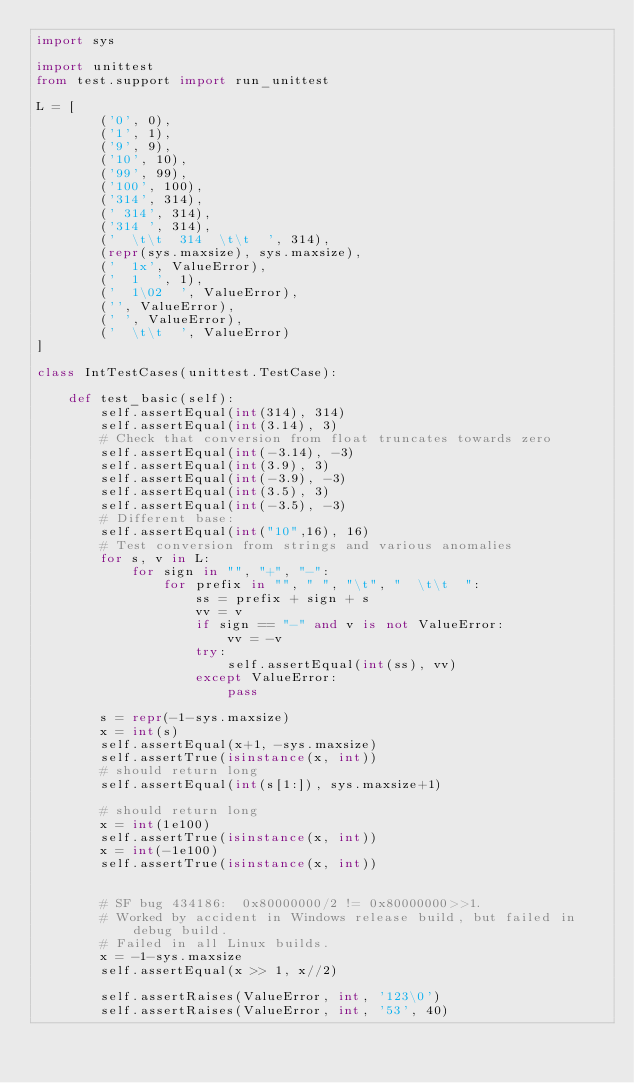<code> <loc_0><loc_0><loc_500><loc_500><_Python_>import sys

import unittest
from test.support import run_unittest

L = [
        ('0', 0),
        ('1', 1),
        ('9', 9),
        ('10', 10),
        ('99', 99),
        ('100', 100),
        ('314', 314),
        (' 314', 314),
        ('314 ', 314),
        ('  \t\t  314  \t\t  ', 314),
        (repr(sys.maxsize), sys.maxsize),
        ('  1x', ValueError),
        ('  1  ', 1),
        ('  1\02  ', ValueError),
        ('', ValueError),
        (' ', ValueError),
        ('  \t\t  ', ValueError)
]

class IntTestCases(unittest.TestCase):

    def test_basic(self):
        self.assertEqual(int(314), 314)
        self.assertEqual(int(3.14), 3)
        # Check that conversion from float truncates towards zero
        self.assertEqual(int(-3.14), -3)
        self.assertEqual(int(3.9), 3)
        self.assertEqual(int(-3.9), -3)
        self.assertEqual(int(3.5), 3)
        self.assertEqual(int(-3.5), -3)
        # Different base:
        self.assertEqual(int("10",16), 16)
        # Test conversion from strings and various anomalies
        for s, v in L:
            for sign in "", "+", "-":
                for prefix in "", " ", "\t", "  \t\t  ":
                    ss = prefix + sign + s
                    vv = v
                    if sign == "-" and v is not ValueError:
                        vv = -v
                    try:
                        self.assertEqual(int(ss), vv)
                    except ValueError:
                        pass

        s = repr(-1-sys.maxsize)
        x = int(s)
        self.assertEqual(x+1, -sys.maxsize)
        self.assertTrue(isinstance(x, int))
        # should return long
        self.assertEqual(int(s[1:]), sys.maxsize+1)

        # should return long
        x = int(1e100)
        self.assertTrue(isinstance(x, int))
        x = int(-1e100)
        self.assertTrue(isinstance(x, int))


        # SF bug 434186:  0x80000000/2 != 0x80000000>>1.
        # Worked by accident in Windows release build, but failed in debug build.
        # Failed in all Linux builds.
        x = -1-sys.maxsize
        self.assertEqual(x >> 1, x//2)

        self.assertRaises(ValueError, int, '123\0')
        self.assertRaises(ValueError, int, '53', 40)
</code> 